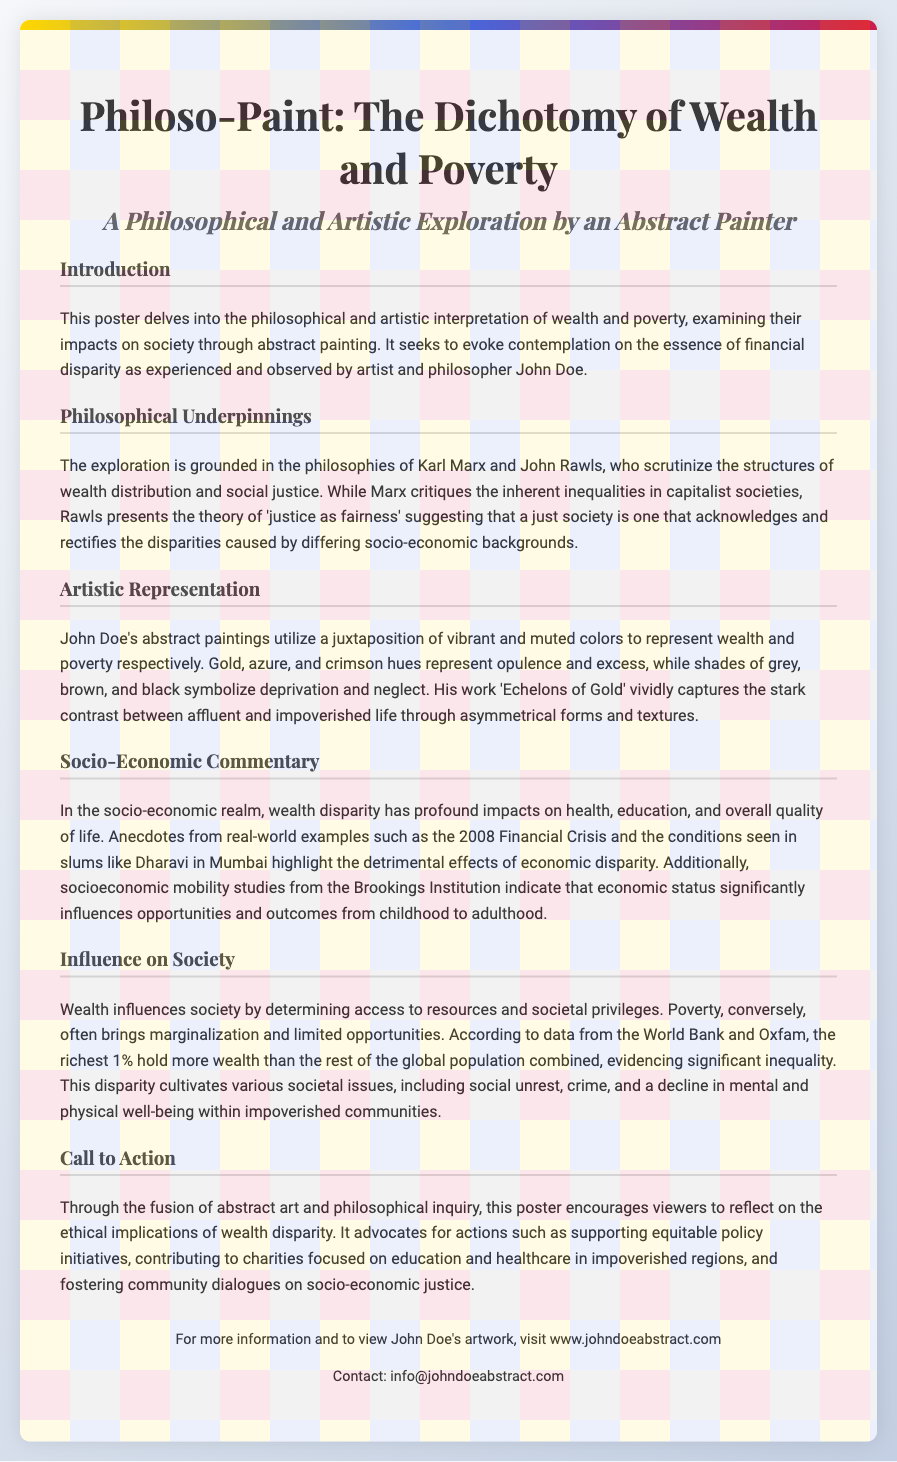What is the title of the poster? The title is explicitly stated at the top of the poster.
Answer: Philoso-Paint: The Dichotomy of Wealth and Poverty Who is the artist mentioned in the poster? The artist's name is provided in the introductory section.
Answer: John Doe What philosophical theory is associated with John Rawls in the document? The document states the theory related to social justice discussed by John Rawls.
Answer: Justice as fairness Which artwork by John Doe is mentioned in the poster? The specific artwork is referenced under the artistic representation section.
Answer: Echelons of Gold What two colors represent opulence and excess in the abstract paintings? The colors are described in the artistic representation section.
Answer: Gold, azure What is one effect of wealth disparity mentioned in the socio-economic commentary? The document provides examples of impacts of economic disparity on society.
Answer: Health What organization is referenced regarding socioeconomic mobility studies? The specific organization is cited in the socio-economic commentary section.
Answer: Brookings Institution What type of dialogue does the poster advocate for? The call to action encourages a specific kind of discussion related to socio-economic issues.
Answer: Community dialogues on socio-economic justice How does the poster suggest addressing wealth disparity? The call to action contains suggestions for actions to combat economic inequality.
Answer: Support equitable policy initiatives 